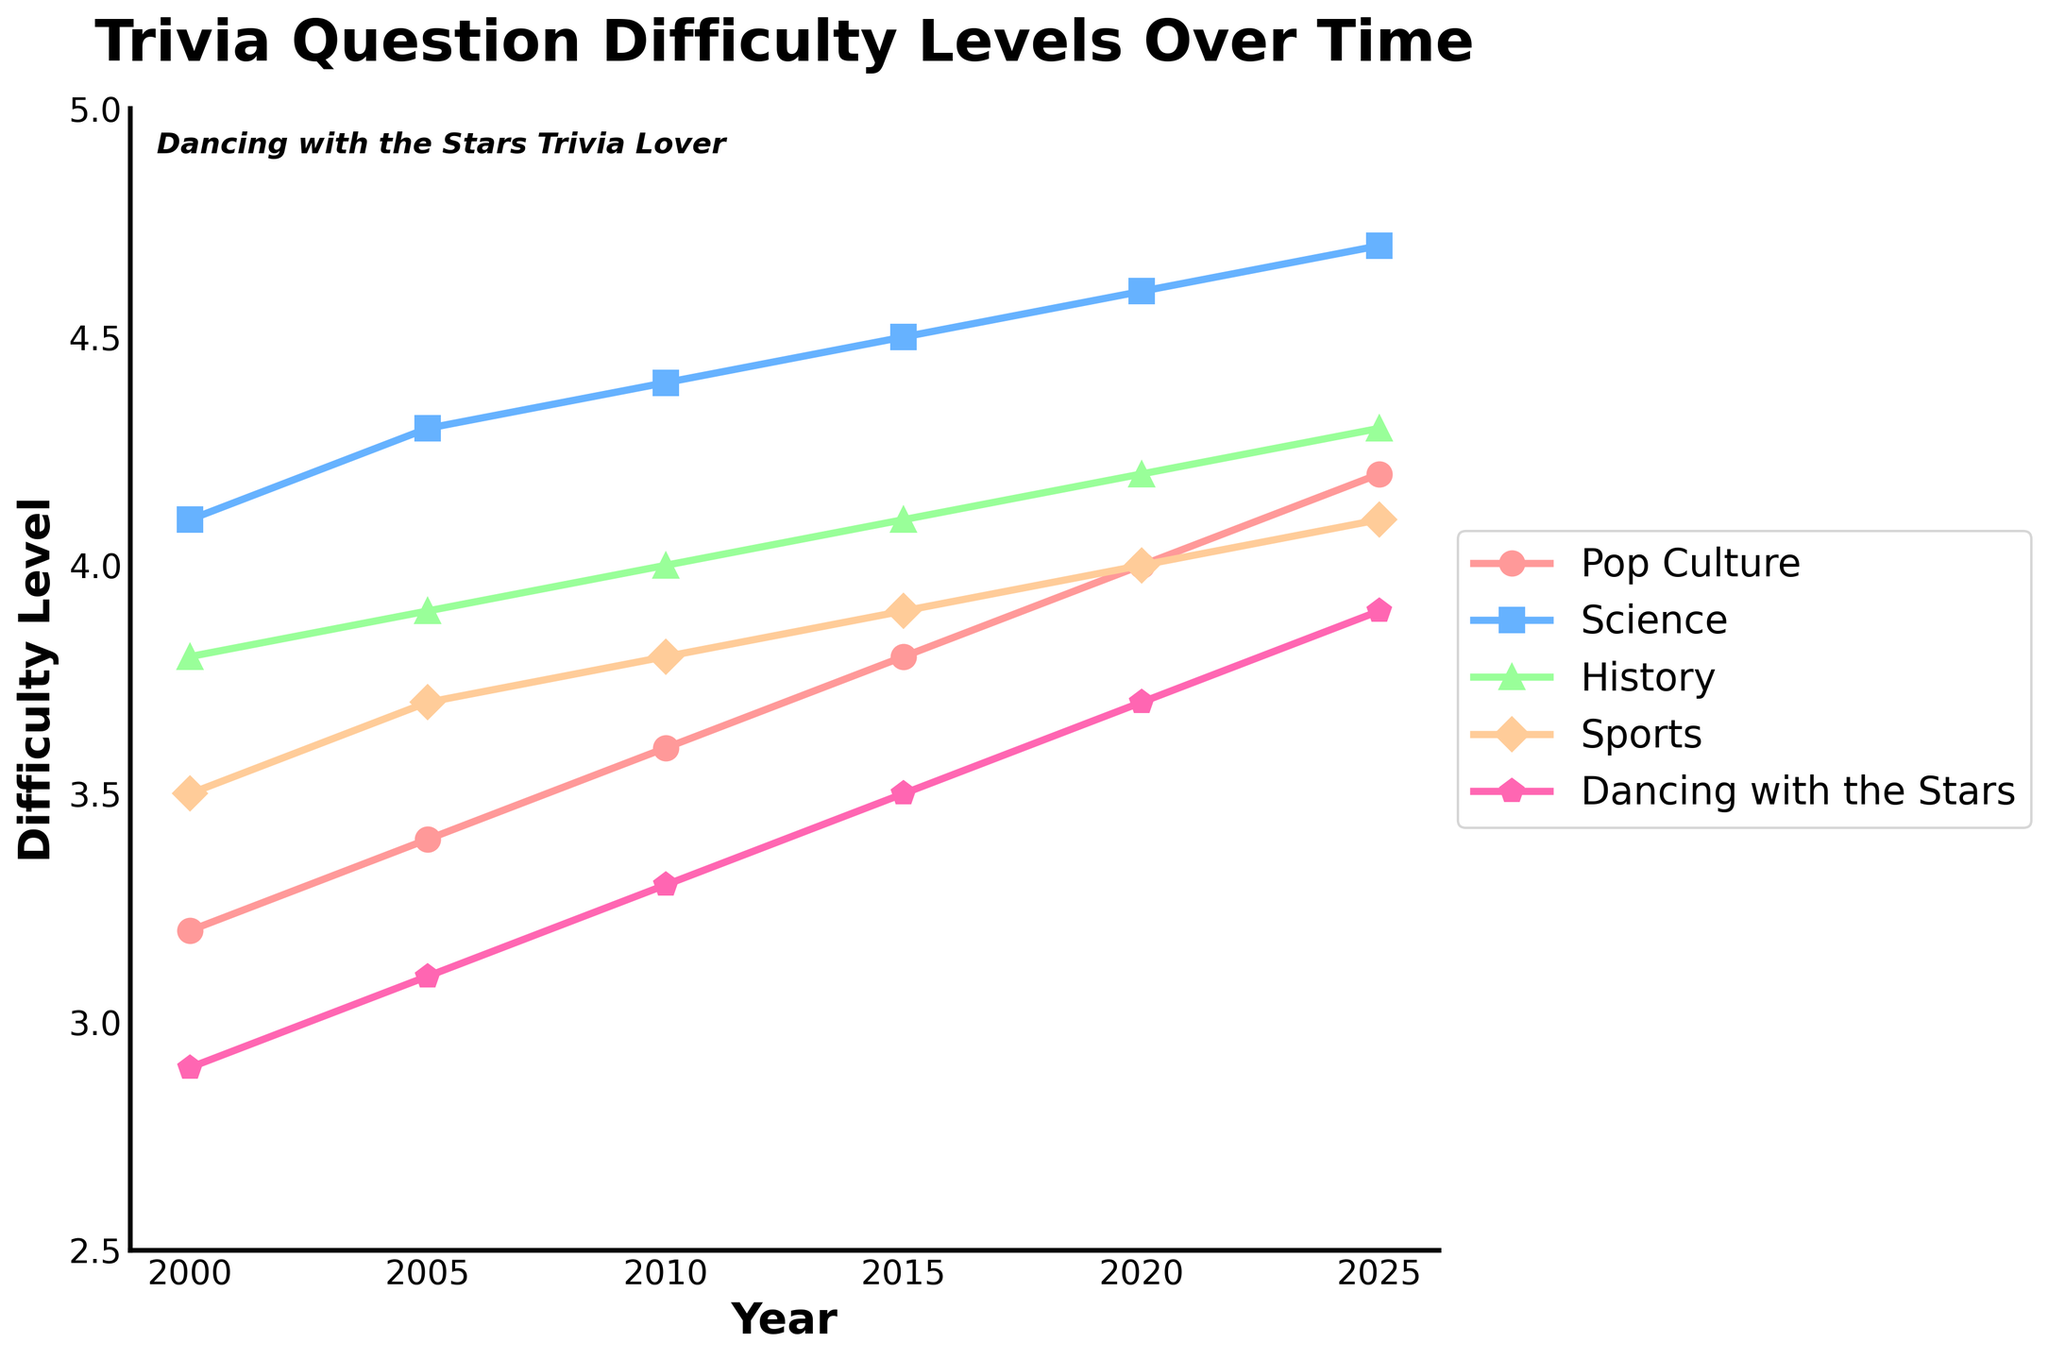Which subject area had the highest difficulty level in the year 2020? Observe the data points for the year 2020 and compare the values across the subject areas. Science had the highest value of 4.6 in 2020.
Answer: Science Did the difficulty level of Pop Culture increase or decrease from 2000 to 2025? Check the values for Pop Culture in the years 2000 (3.2) and 2025 (4.2). The difficulty level increased.
Answer: Increase By how much did the difficulty level of Dancing with the Stars increase from 2005 to 2025? Subtract the value of Dancing with the Stars in 2005 (3.1) from the value in 2025 (3.9). The increase is 3.9 - 3.1 = 0.8.
Answer: 0.8 Which year shows the least difficulty level for History across all the years mentioned? Compare the values for History across all years. The least value is in 2000, which is 3.8.
Answer: 2000 What is the average difficulty level of Science from 2000 to 2025? Add all the Science values (4.1 + 4.3 + 4.4 + 4.5 + 4.6 + 4.7) and then divide by the number of years (6). The average is (4.1 + 4.3 + 4.4 + 4.5 + 4.6 + 4.7) / 6 = 4.433.
Answer: 4.433 Which color represents the Pop Culture line on the plot? Identify the color associated with Pop Culture in the legend of the plot. It is represented by red.
Answer: Red Did the difficulty level for Sports in 2010 exceed the difficulty level for History in the same year? Compare the values for Sports (3.8) and History (4.0) in 2010. Sports did not exceed History.
Answer: No What is the combined difficulty level of History and Sports in 2015? Sum the values of History (4.1) and Sports (3.9) in 2015. The result is 4.1 + 3.9 = 8.
Answer: 8 Which subject area shows the most consistent increase in difficulty level from 2000 to 2025? Observe the trends for all subject areas, looking at the increase year by year. Pop Culture shows a consistent increase across this period.
Answer: Pop Culture What is the difference in the difficulty levels of Science and Pop Culture in 2025? Subtract the value of Pop Culture (4.2) from the value of Science (4.7) in 2025. The difference is 4.7 - 4.2 = 0.5.
Answer: 0.5 